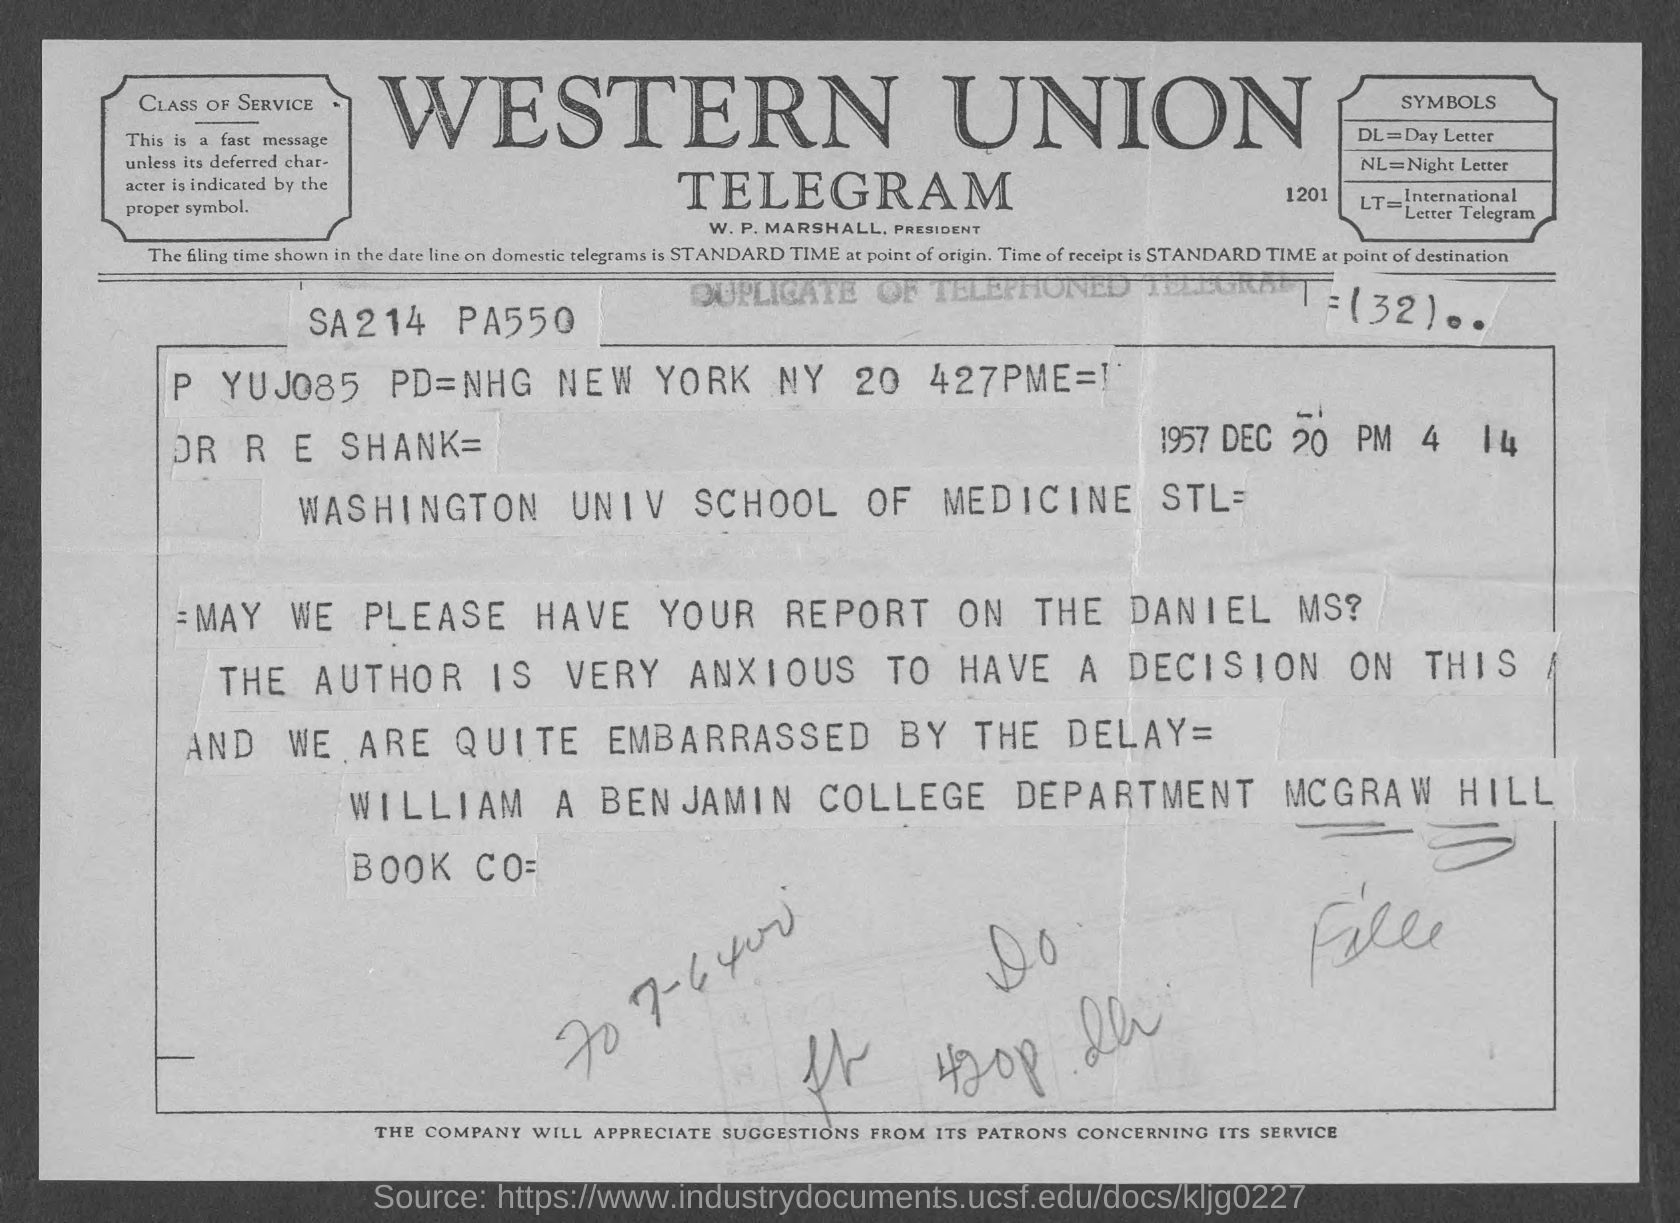What does DL stand for?
Your answer should be compact. Day Letter. What does NL stand for?
Ensure brevity in your answer.  Night Letter. What does LT stand for?
Make the answer very short. International Letter Telegram. What is the date on the document?
Keep it short and to the point. 1957 DEC 20. Who is this letter from?
Provide a succinct answer. WILLIAM A BENJAMIN. 